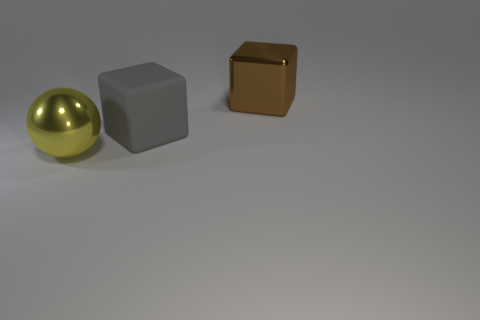What number of yellow metallic objects are in front of the large yellow thing?
Your answer should be compact. 0. How many things are things that are on the left side of the brown cube or brown metallic objects?
Your response must be concise. 3. Is the number of shiny blocks in front of the large brown object greater than the number of metallic spheres right of the shiny ball?
Provide a succinct answer. No. Is the size of the gray matte cube the same as the shiny thing that is right of the large metal ball?
Ensure brevity in your answer.  Yes. How many cylinders are either brown shiny objects or big yellow objects?
Keep it short and to the point. 0. The brown cube that is the same material as the big yellow object is what size?
Offer a terse response. Large. Do the brown metallic block to the right of the matte cube and the block to the left of the large brown block have the same size?
Offer a very short reply. Yes. What number of things are tiny blue shiny cylinders or big metallic things?
Your answer should be compact. 2. What shape is the big yellow thing?
Offer a terse response. Sphere. The other thing that is the same shape as the gray matte object is what size?
Offer a terse response. Large. 